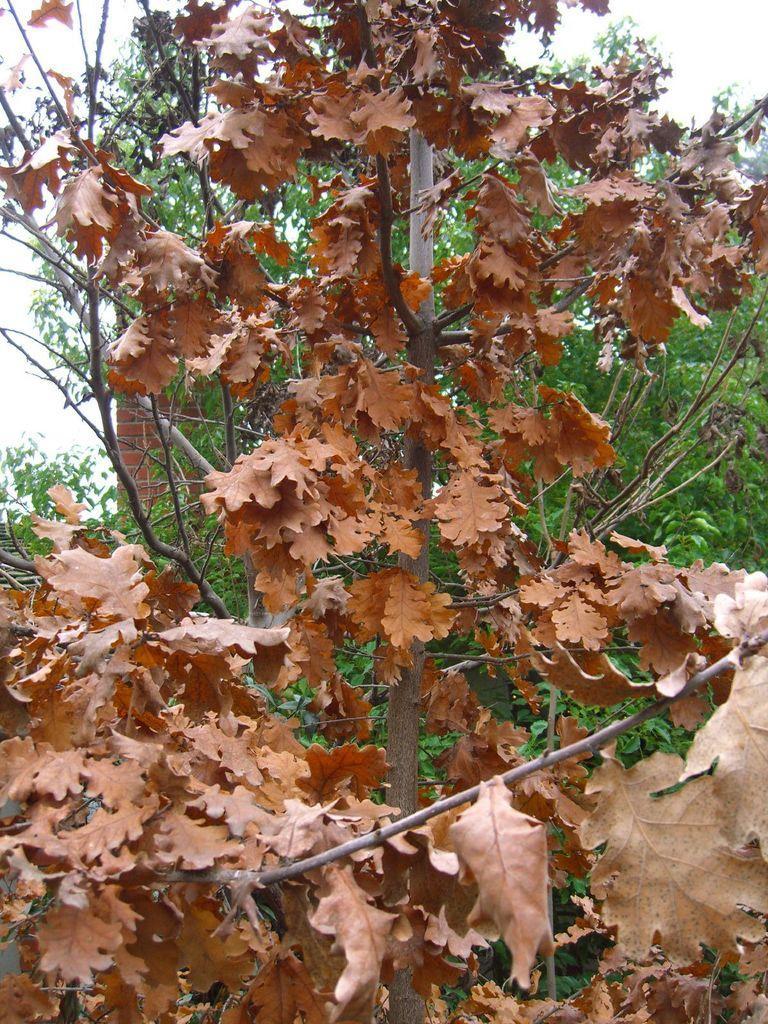How would you summarize this image in a sentence or two? Front we can see a dried plant with dried leaves. Background there is a tree and brick wall. 